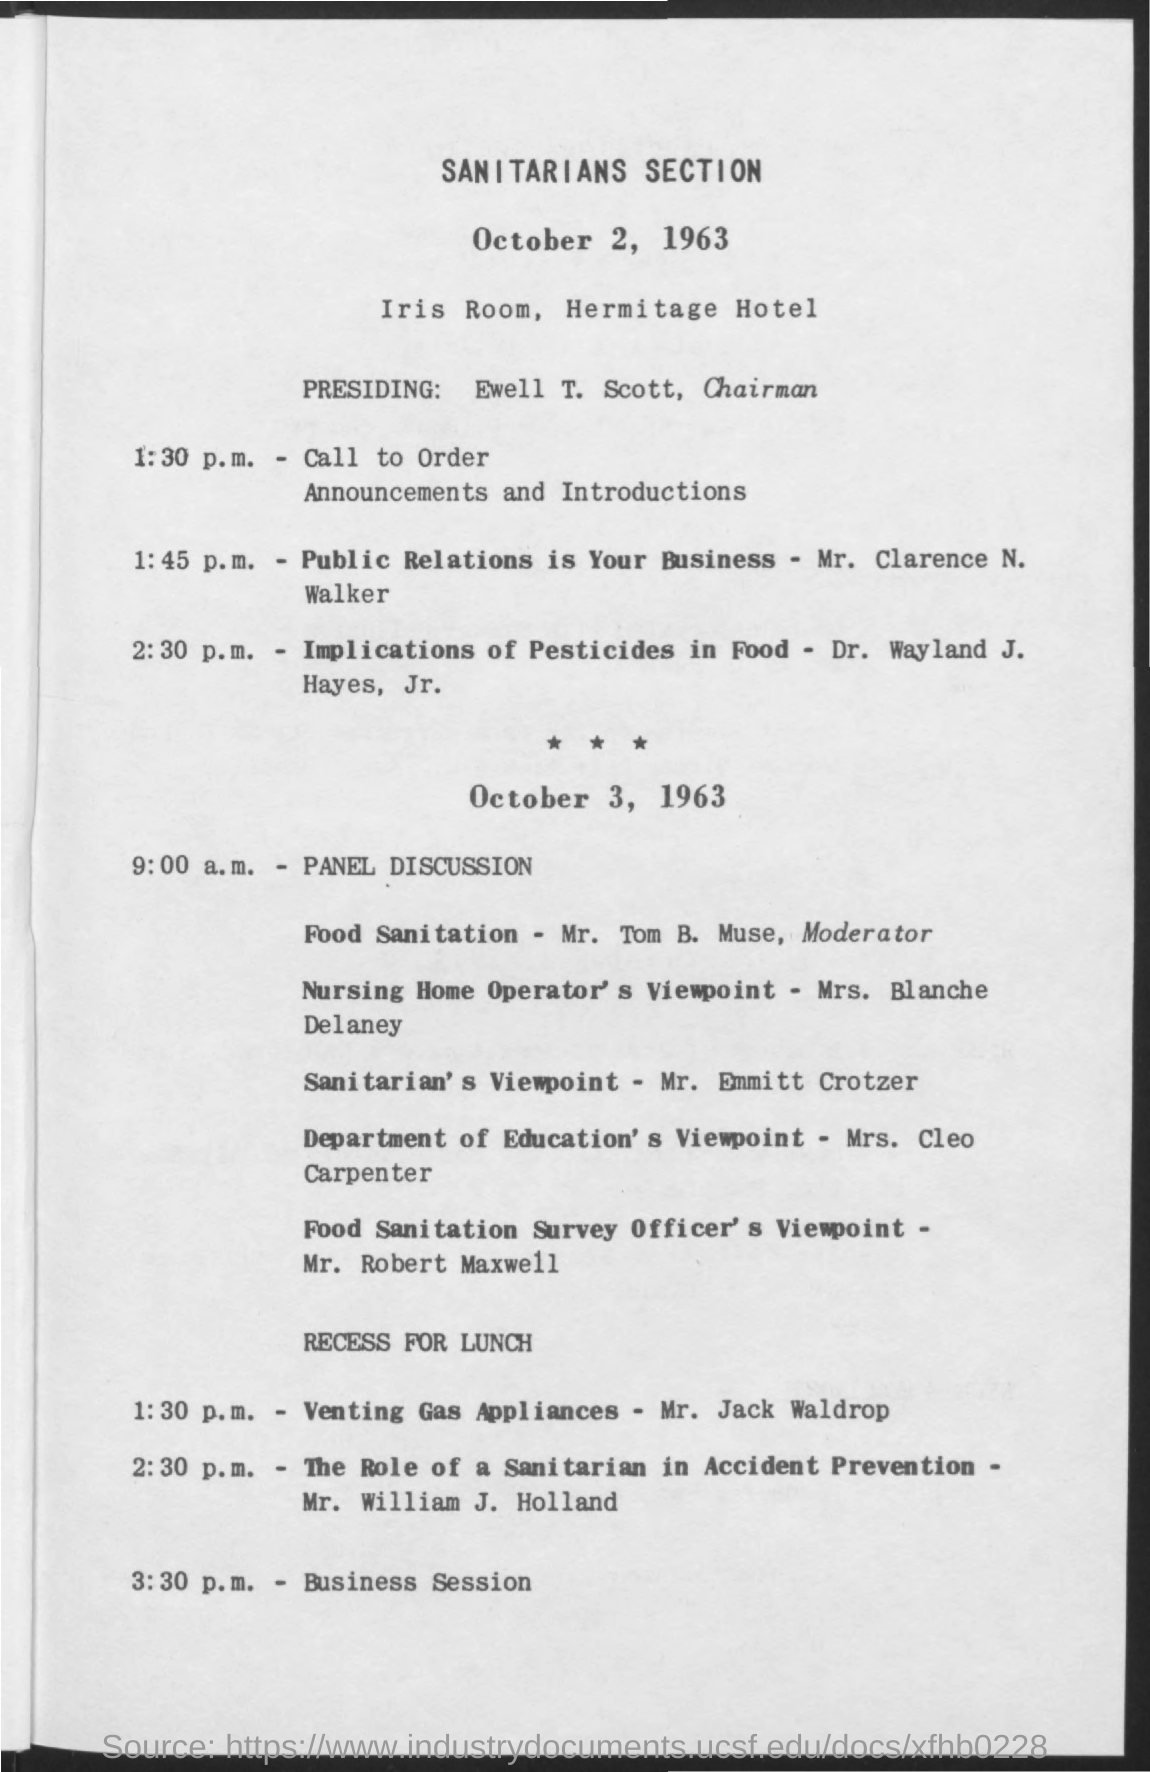what is the time mentioned for business session The business session is scheduled for 3:30 p.m. on October 3, 1963, according to the agenda for the Sanitarians Section meeting held at the Iris Room, Hermitage Hotel. 